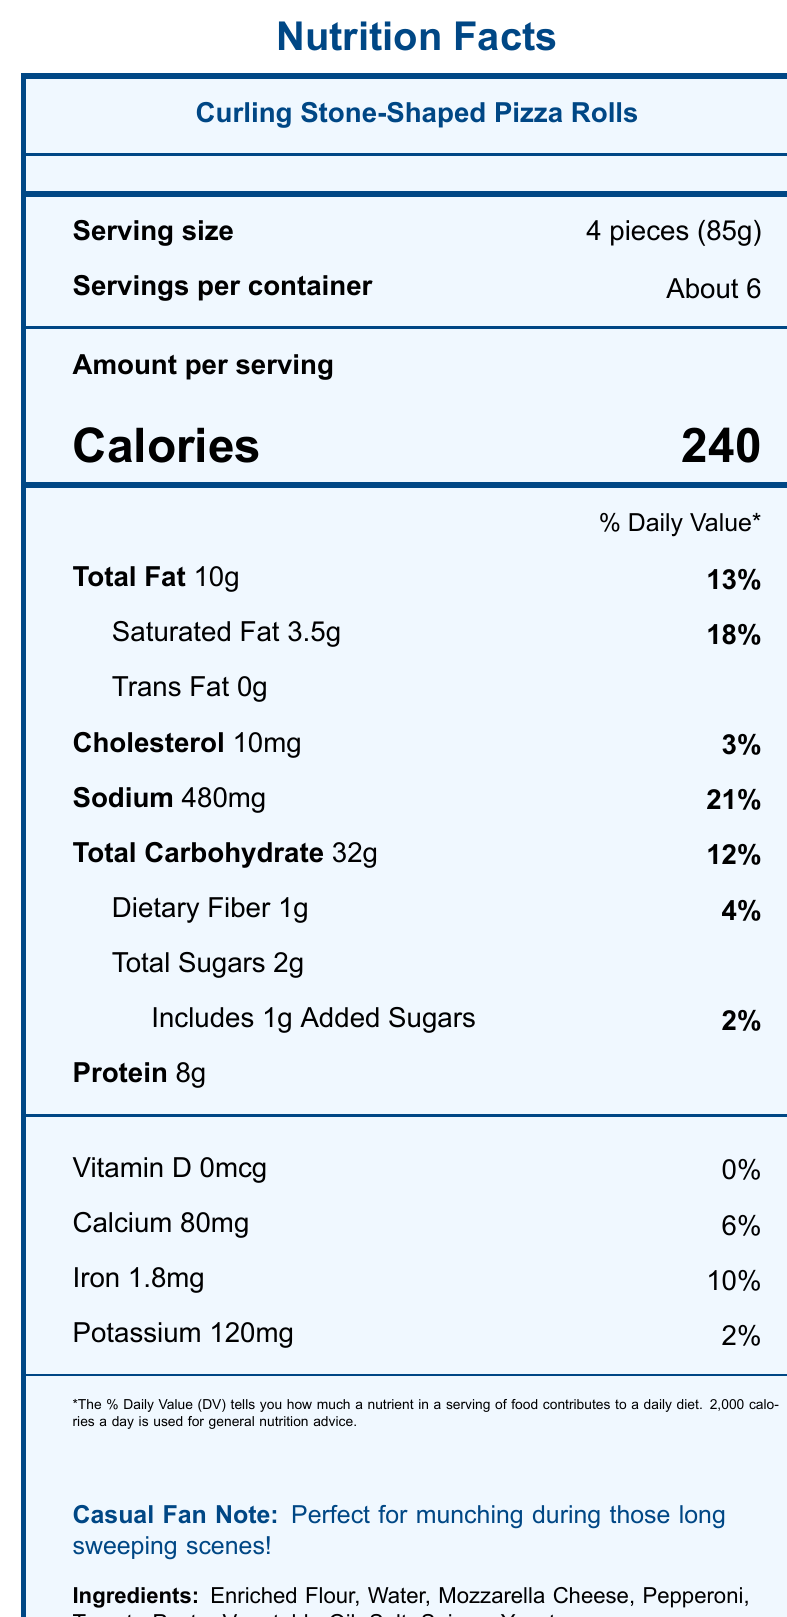What is the serving size for Curling Stone-Shaped Pizza Rolls? The document states "Serving size: 4 pieces (85g)" under the Nutrition Facts section.
Answer: 4 pieces (85g) How many servings are there per container? The document lists "Servings per container: About 6."
Answer: About 6 How many calories are in one serving of these pizza rolls? The document specifies "Calories: 240" in the Amount per Serving section.
Answer: 240 What percentage of the daily value does 10g of Total Fat represent? The document shows "Total Fat 10g: 13%" in the nutrition details.
Answer: 13% Does this product contain any trans fat? The document indicates "Trans Fat 0g," which means there is no trans fat.
Answer: No What are the two main allergens present in this product? The allergens section states "Contains: Wheat, Milk".
Answer: Wheat and Milk How much sodium is in one serving, and what percentage of the daily value does that represent? The document notes "Sodium: 480mg: 21%".
Answer: 480mg, 21% What is the total amount of sugars in one serving, including added sugars? The document lists "Total Sugars: 2g" and "Includes 1g Added Sugars".
Answer: 2g (1g added sugars) Which of the following is an ingredient in the pizza rolls? A. Sugar B. Enriched Flour C. Corn Syrup The ingredients list includes "Enriched Flour," but not sugar or corn syrup.
Answer: B What is the daily value percentage for iron in this product? A. 2% B. 4% C. 10% D. 18% The document states "Iron 1.8mg: 10%" in the nutrition details.
Answer: C Does this product contain any Vitamin D? The document shows "Vitamin D 0mcg: 0%," indicating there is no Vitamin D.
Answer: No Summarize the main idea of this document. The document provides nutritional details such as serving size, calories, and nutrient percentages, as well as an ingredients list and allergens information. It includes a suggestion for casual curling fans.
Answer: This document is a Nutrition Facts label for Curling Stone-Shaped Pizza Rolls, providing detailed information about serving size, calories, nutrients, ingredients, and allergens. It notes that the product is perfect for casual curling fans. What is the storage instruction given for this product? The document includes the storage instruction "Keep frozen. Cook thoroughly before serving."
Answer: Keep frozen. Cook thoroughly before serving. How much protein is in one serving? The document notes "Protein: 8g" in the nutrition details.
Answer: 8g What are the spices used in this product? The document lists "Spices" as an ingredient but does not specify which spices are used.
Answer: Not enough information 